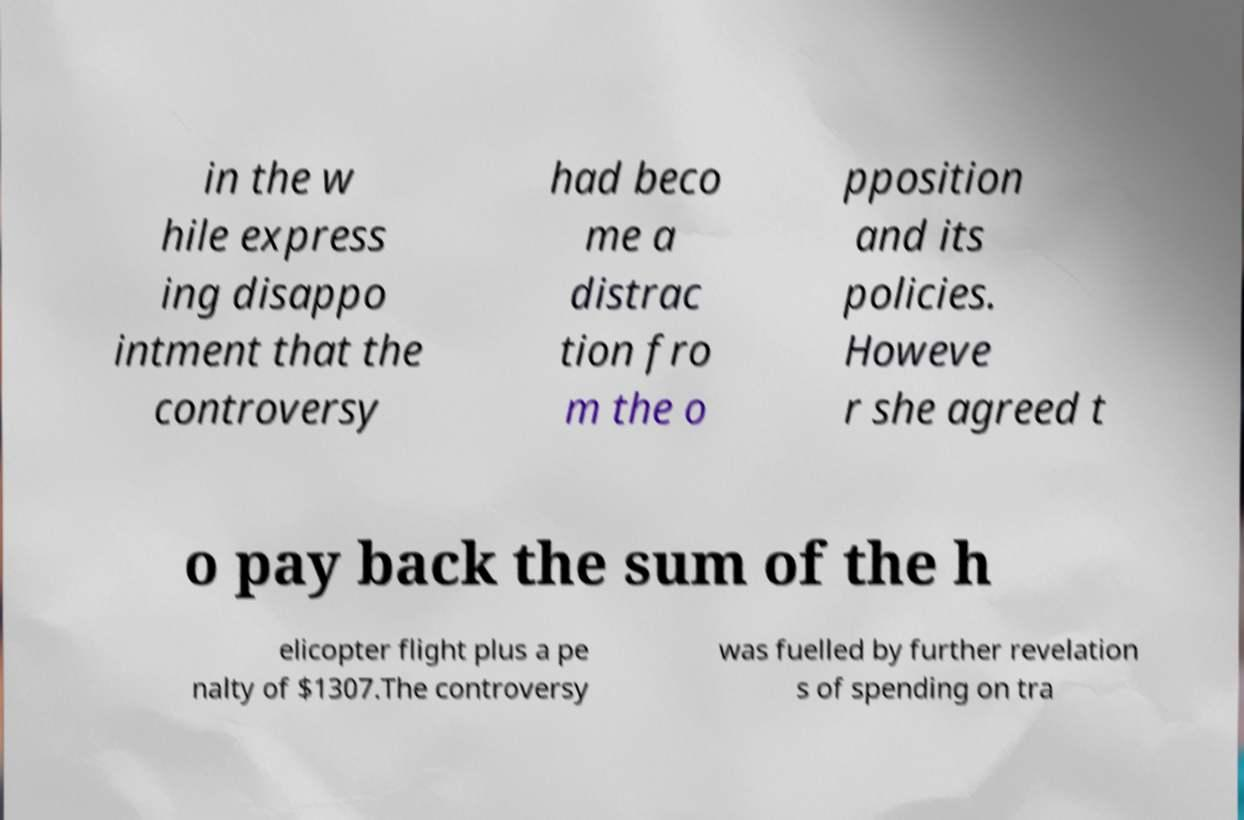Can you accurately transcribe the text from the provided image for me? in the w hile express ing disappo intment that the controversy had beco me a distrac tion fro m the o pposition and its policies. Howeve r she agreed t o pay back the sum of the h elicopter flight plus a pe nalty of $1307.The controversy was fuelled by further revelation s of spending on tra 